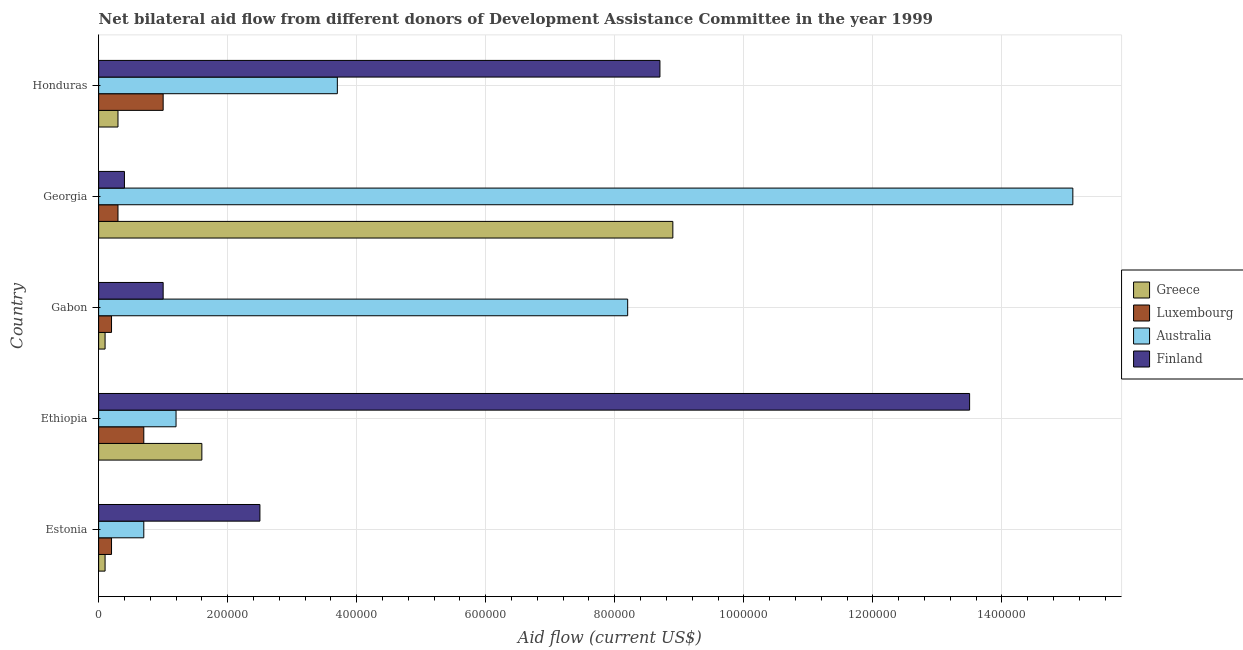How many different coloured bars are there?
Provide a succinct answer. 4. How many groups of bars are there?
Your response must be concise. 5. Are the number of bars per tick equal to the number of legend labels?
Give a very brief answer. Yes. Are the number of bars on each tick of the Y-axis equal?
Offer a very short reply. Yes. How many bars are there on the 3rd tick from the top?
Your answer should be very brief. 4. What is the label of the 4th group of bars from the top?
Give a very brief answer. Ethiopia. In how many cases, is the number of bars for a given country not equal to the number of legend labels?
Your response must be concise. 0. What is the amount of aid given by luxembourg in Georgia?
Your response must be concise. 3.00e+04. Across all countries, what is the maximum amount of aid given by australia?
Provide a short and direct response. 1.51e+06. Across all countries, what is the minimum amount of aid given by finland?
Make the answer very short. 4.00e+04. In which country was the amount of aid given by greece maximum?
Offer a terse response. Georgia. In which country was the amount of aid given by greece minimum?
Your answer should be very brief. Estonia. What is the total amount of aid given by finland in the graph?
Your response must be concise. 2.61e+06. What is the difference between the amount of aid given by australia in Estonia and the amount of aid given by greece in Gabon?
Your answer should be very brief. 6.00e+04. What is the difference between the amount of aid given by luxembourg and amount of aid given by greece in Gabon?
Ensure brevity in your answer.  10000. What is the ratio of the amount of aid given by greece in Gabon to that in Honduras?
Provide a short and direct response. 0.33. Is the amount of aid given by greece in Gabon less than that in Honduras?
Make the answer very short. Yes. Is the difference between the amount of aid given by finland in Estonia and Gabon greater than the difference between the amount of aid given by greece in Estonia and Gabon?
Make the answer very short. Yes. What is the difference between the highest and the lowest amount of aid given by finland?
Your answer should be very brief. 1.31e+06. Is the sum of the amount of aid given by finland in Ethiopia and Honduras greater than the maximum amount of aid given by greece across all countries?
Offer a very short reply. Yes. Is it the case that in every country, the sum of the amount of aid given by greece and amount of aid given by finland is greater than the sum of amount of aid given by luxembourg and amount of aid given by australia?
Ensure brevity in your answer.  Yes. Is it the case that in every country, the sum of the amount of aid given by greece and amount of aid given by luxembourg is greater than the amount of aid given by australia?
Ensure brevity in your answer.  No. Are all the bars in the graph horizontal?
Provide a short and direct response. Yes. How many countries are there in the graph?
Ensure brevity in your answer.  5. Does the graph contain any zero values?
Your answer should be very brief. No. How many legend labels are there?
Your answer should be compact. 4. What is the title of the graph?
Give a very brief answer. Net bilateral aid flow from different donors of Development Assistance Committee in the year 1999. What is the label or title of the Y-axis?
Offer a very short reply. Country. What is the Aid flow (current US$) in Greece in Estonia?
Make the answer very short. 10000. What is the Aid flow (current US$) in Luxembourg in Estonia?
Ensure brevity in your answer.  2.00e+04. What is the Aid flow (current US$) of Australia in Estonia?
Offer a terse response. 7.00e+04. What is the Aid flow (current US$) of Finland in Estonia?
Ensure brevity in your answer.  2.50e+05. What is the Aid flow (current US$) of Greece in Ethiopia?
Your response must be concise. 1.60e+05. What is the Aid flow (current US$) in Finland in Ethiopia?
Offer a terse response. 1.35e+06. What is the Aid flow (current US$) in Australia in Gabon?
Offer a terse response. 8.20e+05. What is the Aid flow (current US$) of Finland in Gabon?
Your response must be concise. 1.00e+05. What is the Aid flow (current US$) in Greece in Georgia?
Provide a succinct answer. 8.90e+05. What is the Aid flow (current US$) of Luxembourg in Georgia?
Keep it short and to the point. 3.00e+04. What is the Aid flow (current US$) in Australia in Georgia?
Your answer should be compact. 1.51e+06. What is the Aid flow (current US$) in Finland in Georgia?
Ensure brevity in your answer.  4.00e+04. What is the Aid flow (current US$) in Greece in Honduras?
Provide a short and direct response. 3.00e+04. What is the Aid flow (current US$) in Australia in Honduras?
Offer a very short reply. 3.70e+05. What is the Aid flow (current US$) of Finland in Honduras?
Keep it short and to the point. 8.70e+05. Across all countries, what is the maximum Aid flow (current US$) of Greece?
Make the answer very short. 8.90e+05. Across all countries, what is the maximum Aid flow (current US$) of Luxembourg?
Keep it short and to the point. 1.00e+05. Across all countries, what is the maximum Aid flow (current US$) in Australia?
Provide a short and direct response. 1.51e+06. Across all countries, what is the maximum Aid flow (current US$) in Finland?
Give a very brief answer. 1.35e+06. Across all countries, what is the minimum Aid flow (current US$) of Greece?
Make the answer very short. 10000. What is the total Aid flow (current US$) of Greece in the graph?
Offer a terse response. 1.10e+06. What is the total Aid flow (current US$) of Australia in the graph?
Your response must be concise. 2.89e+06. What is the total Aid flow (current US$) of Finland in the graph?
Keep it short and to the point. 2.61e+06. What is the difference between the Aid flow (current US$) of Greece in Estonia and that in Ethiopia?
Ensure brevity in your answer.  -1.50e+05. What is the difference between the Aid flow (current US$) in Australia in Estonia and that in Ethiopia?
Provide a succinct answer. -5.00e+04. What is the difference between the Aid flow (current US$) in Finland in Estonia and that in Ethiopia?
Provide a succinct answer. -1.10e+06. What is the difference between the Aid flow (current US$) of Greece in Estonia and that in Gabon?
Provide a short and direct response. 0. What is the difference between the Aid flow (current US$) of Luxembourg in Estonia and that in Gabon?
Offer a terse response. 0. What is the difference between the Aid flow (current US$) of Australia in Estonia and that in Gabon?
Provide a short and direct response. -7.50e+05. What is the difference between the Aid flow (current US$) in Greece in Estonia and that in Georgia?
Offer a very short reply. -8.80e+05. What is the difference between the Aid flow (current US$) in Luxembourg in Estonia and that in Georgia?
Keep it short and to the point. -10000. What is the difference between the Aid flow (current US$) of Australia in Estonia and that in Georgia?
Your answer should be compact. -1.44e+06. What is the difference between the Aid flow (current US$) in Finland in Estonia and that in Georgia?
Offer a terse response. 2.10e+05. What is the difference between the Aid flow (current US$) of Luxembourg in Estonia and that in Honduras?
Offer a very short reply. -8.00e+04. What is the difference between the Aid flow (current US$) in Australia in Estonia and that in Honduras?
Your answer should be compact. -3.00e+05. What is the difference between the Aid flow (current US$) of Finland in Estonia and that in Honduras?
Provide a succinct answer. -6.20e+05. What is the difference between the Aid flow (current US$) in Australia in Ethiopia and that in Gabon?
Your response must be concise. -7.00e+05. What is the difference between the Aid flow (current US$) in Finland in Ethiopia and that in Gabon?
Make the answer very short. 1.25e+06. What is the difference between the Aid flow (current US$) in Greece in Ethiopia and that in Georgia?
Offer a very short reply. -7.30e+05. What is the difference between the Aid flow (current US$) of Luxembourg in Ethiopia and that in Georgia?
Your response must be concise. 4.00e+04. What is the difference between the Aid flow (current US$) of Australia in Ethiopia and that in Georgia?
Give a very brief answer. -1.39e+06. What is the difference between the Aid flow (current US$) of Finland in Ethiopia and that in Georgia?
Ensure brevity in your answer.  1.31e+06. What is the difference between the Aid flow (current US$) in Finland in Ethiopia and that in Honduras?
Your response must be concise. 4.80e+05. What is the difference between the Aid flow (current US$) in Greece in Gabon and that in Georgia?
Make the answer very short. -8.80e+05. What is the difference between the Aid flow (current US$) of Australia in Gabon and that in Georgia?
Your answer should be very brief. -6.90e+05. What is the difference between the Aid flow (current US$) in Finland in Gabon and that in Honduras?
Offer a terse response. -7.70e+05. What is the difference between the Aid flow (current US$) of Greece in Georgia and that in Honduras?
Offer a very short reply. 8.60e+05. What is the difference between the Aid flow (current US$) in Australia in Georgia and that in Honduras?
Your answer should be very brief. 1.14e+06. What is the difference between the Aid flow (current US$) in Finland in Georgia and that in Honduras?
Provide a short and direct response. -8.30e+05. What is the difference between the Aid flow (current US$) in Greece in Estonia and the Aid flow (current US$) in Luxembourg in Ethiopia?
Make the answer very short. -6.00e+04. What is the difference between the Aid flow (current US$) of Greece in Estonia and the Aid flow (current US$) of Australia in Ethiopia?
Your answer should be very brief. -1.10e+05. What is the difference between the Aid flow (current US$) in Greece in Estonia and the Aid flow (current US$) in Finland in Ethiopia?
Your answer should be compact. -1.34e+06. What is the difference between the Aid flow (current US$) in Luxembourg in Estonia and the Aid flow (current US$) in Finland in Ethiopia?
Keep it short and to the point. -1.33e+06. What is the difference between the Aid flow (current US$) in Australia in Estonia and the Aid flow (current US$) in Finland in Ethiopia?
Offer a terse response. -1.28e+06. What is the difference between the Aid flow (current US$) of Greece in Estonia and the Aid flow (current US$) of Luxembourg in Gabon?
Keep it short and to the point. -10000. What is the difference between the Aid flow (current US$) of Greece in Estonia and the Aid flow (current US$) of Australia in Gabon?
Offer a terse response. -8.10e+05. What is the difference between the Aid flow (current US$) in Greece in Estonia and the Aid flow (current US$) in Finland in Gabon?
Give a very brief answer. -9.00e+04. What is the difference between the Aid flow (current US$) of Luxembourg in Estonia and the Aid flow (current US$) of Australia in Gabon?
Ensure brevity in your answer.  -8.00e+05. What is the difference between the Aid flow (current US$) of Luxembourg in Estonia and the Aid flow (current US$) of Finland in Gabon?
Offer a very short reply. -8.00e+04. What is the difference between the Aid flow (current US$) of Australia in Estonia and the Aid flow (current US$) of Finland in Gabon?
Offer a very short reply. -3.00e+04. What is the difference between the Aid flow (current US$) of Greece in Estonia and the Aid flow (current US$) of Luxembourg in Georgia?
Provide a short and direct response. -2.00e+04. What is the difference between the Aid flow (current US$) in Greece in Estonia and the Aid flow (current US$) in Australia in Georgia?
Provide a succinct answer. -1.50e+06. What is the difference between the Aid flow (current US$) of Greece in Estonia and the Aid flow (current US$) of Finland in Georgia?
Offer a terse response. -3.00e+04. What is the difference between the Aid flow (current US$) in Luxembourg in Estonia and the Aid flow (current US$) in Australia in Georgia?
Offer a terse response. -1.49e+06. What is the difference between the Aid flow (current US$) of Greece in Estonia and the Aid flow (current US$) of Australia in Honduras?
Provide a short and direct response. -3.60e+05. What is the difference between the Aid flow (current US$) in Greece in Estonia and the Aid flow (current US$) in Finland in Honduras?
Make the answer very short. -8.60e+05. What is the difference between the Aid flow (current US$) in Luxembourg in Estonia and the Aid flow (current US$) in Australia in Honduras?
Your response must be concise. -3.50e+05. What is the difference between the Aid flow (current US$) in Luxembourg in Estonia and the Aid flow (current US$) in Finland in Honduras?
Make the answer very short. -8.50e+05. What is the difference between the Aid flow (current US$) of Australia in Estonia and the Aid flow (current US$) of Finland in Honduras?
Offer a very short reply. -8.00e+05. What is the difference between the Aid flow (current US$) in Greece in Ethiopia and the Aid flow (current US$) in Australia in Gabon?
Offer a very short reply. -6.60e+05. What is the difference between the Aid flow (current US$) of Luxembourg in Ethiopia and the Aid flow (current US$) of Australia in Gabon?
Give a very brief answer. -7.50e+05. What is the difference between the Aid flow (current US$) in Australia in Ethiopia and the Aid flow (current US$) in Finland in Gabon?
Ensure brevity in your answer.  2.00e+04. What is the difference between the Aid flow (current US$) in Greece in Ethiopia and the Aid flow (current US$) in Australia in Georgia?
Offer a terse response. -1.35e+06. What is the difference between the Aid flow (current US$) in Greece in Ethiopia and the Aid flow (current US$) in Finland in Georgia?
Provide a succinct answer. 1.20e+05. What is the difference between the Aid flow (current US$) of Luxembourg in Ethiopia and the Aid flow (current US$) of Australia in Georgia?
Ensure brevity in your answer.  -1.44e+06. What is the difference between the Aid flow (current US$) of Australia in Ethiopia and the Aid flow (current US$) of Finland in Georgia?
Provide a short and direct response. 8.00e+04. What is the difference between the Aid flow (current US$) of Greece in Ethiopia and the Aid flow (current US$) of Luxembourg in Honduras?
Your answer should be very brief. 6.00e+04. What is the difference between the Aid flow (current US$) in Greece in Ethiopia and the Aid flow (current US$) in Australia in Honduras?
Ensure brevity in your answer.  -2.10e+05. What is the difference between the Aid flow (current US$) of Greece in Ethiopia and the Aid flow (current US$) of Finland in Honduras?
Your answer should be very brief. -7.10e+05. What is the difference between the Aid flow (current US$) of Luxembourg in Ethiopia and the Aid flow (current US$) of Australia in Honduras?
Your answer should be very brief. -3.00e+05. What is the difference between the Aid flow (current US$) of Luxembourg in Ethiopia and the Aid flow (current US$) of Finland in Honduras?
Offer a terse response. -8.00e+05. What is the difference between the Aid flow (current US$) in Australia in Ethiopia and the Aid flow (current US$) in Finland in Honduras?
Your response must be concise. -7.50e+05. What is the difference between the Aid flow (current US$) in Greece in Gabon and the Aid flow (current US$) in Australia in Georgia?
Make the answer very short. -1.50e+06. What is the difference between the Aid flow (current US$) of Greece in Gabon and the Aid flow (current US$) of Finland in Georgia?
Your answer should be compact. -3.00e+04. What is the difference between the Aid flow (current US$) of Luxembourg in Gabon and the Aid flow (current US$) of Australia in Georgia?
Ensure brevity in your answer.  -1.49e+06. What is the difference between the Aid flow (current US$) in Australia in Gabon and the Aid flow (current US$) in Finland in Georgia?
Keep it short and to the point. 7.80e+05. What is the difference between the Aid flow (current US$) of Greece in Gabon and the Aid flow (current US$) of Luxembourg in Honduras?
Provide a succinct answer. -9.00e+04. What is the difference between the Aid flow (current US$) in Greece in Gabon and the Aid flow (current US$) in Australia in Honduras?
Provide a succinct answer. -3.60e+05. What is the difference between the Aid flow (current US$) of Greece in Gabon and the Aid flow (current US$) of Finland in Honduras?
Your response must be concise. -8.60e+05. What is the difference between the Aid flow (current US$) in Luxembourg in Gabon and the Aid flow (current US$) in Australia in Honduras?
Offer a very short reply. -3.50e+05. What is the difference between the Aid flow (current US$) in Luxembourg in Gabon and the Aid flow (current US$) in Finland in Honduras?
Your response must be concise. -8.50e+05. What is the difference between the Aid flow (current US$) in Greece in Georgia and the Aid flow (current US$) in Luxembourg in Honduras?
Make the answer very short. 7.90e+05. What is the difference between the Aid flow (current US$) in Greece in Georgia and the Aid flow (current US$) in Australia in Honduras?
Your answer should be compact. 5.20e+05. What is the difference between the Aid flow (current US$) of Luxembourg in Georgia and the Aid flow (current US$) of Australia in Honduras?
Offer a terse response. -3.40e+05. What is the difference between the Aid flow (current US$) of Luxembourg in Georgia and the Aid flow (current US$) of Finland in Honduras?
Offer a very short reply. -8.40e+05. What is the difference between the Aid flow (current US$) of Australia in Georgia and the Aid flow (current US$) of Finland in Honduras?
Make the answer very short. 6.40e+05. What is the average Aid flow (current US$) of Greece per country?
Offer a terse response. 2.20e+05. What is the average Aid flow (current US$) of Luxembourg per country?
Keep it short and to the point. 4.80e+04. What is the average Aid flow (current US$) of Australia per country?
Make the answer very short. 5.78e+05. What is the average Aid flow (current US$) of Finland per country?
Offer a terse response. 5.22e+05. What is the difference between the Aid flow (current US$) in Greece and Aid flow (current US$) in Luxembourg in Estonia?
Offer a terse response. -10000. What is the difference between the Aid flow (current US$) in Greece and Aid flow (current US$) in Luxembourg in Ethiopia?
Offer a terse response. 9.00e+04. What is the difference between the Aid flow (current US$) of Greece and Aid flow (current US$) of Finland in Ethiopia?
Your response must be concise. -1.19e+06. What is the difference between the Aid flow (current US$) in Luxembourg and Aid flow (current US$) in Australia in Ethiopia?
Your answer should be compact. -5.00e+04. What is the difference between the Aid flow (current US$) in Luxembourg and Aid flow (current US$) in Finland in Ethiopia?
Ensure brevity in your answer.  -1.28e+06. What is the difference between the Aid flow (current US$) in Australia and Aid flow (current US$) in Finland in Ethiopia?
Give a very brief answer. -1.23e+06. What is the difference between the Aid flow (current US$) of Greece and Aid flow (current US$) of Australia in Gabon?
Provide a short and direct response. -8.10e+05. What is the difference between the Aid flow (current US$) of Greece and Aid flow (current US$) of Finland in Gabon?
Offer a terse response. -9.00e+04. What is the difference between the Aid flow (current US$) in Luxembourg and Aid flow (current US$) in Australia in Gabon?
Make the answer very short. -8.00e+05. What is the difference between the Aid flow (current US$) in Australia and Aid flow (current US$) in Finland in Gabon?
Keep it short and to the point. 7.20e+05. What is the difference between the Aid flow (current US$) in Greece and Aid flow (current US$) in Luxembourg in Georgia?
Your answer should be compact. 8.60e+05. What is the difference between the Aid flow (current US$) in Greece and Aid flow (current US$) in Australia in Georgia?
Your answer should be compact. -6.20e+05. What is the difference between the Aid flow (current US$) of Greece and Aid flow (current US$) of Finland in Georgia?
Offer a very short reply. 8.50e+05. What is the difference between the Aid flow (current US$) in Luxembourg and Aid flow (current US$) in Australia in Georgia?
Offer a very short reply. -1.48e+06. What is the difference between the Aid flow (current US$) of Australia and Aid flow (current US$) of Finland in Georgia?
Your answer should be very brief. 1.47e+06. What is the difference between the Aid flow (current US$) of Greece and Aid flow (current US$) of Australia in Honduras?
Give a very brief answer. -3.40e+05. What is the difference between the Aid flow (current US$) in Greece and Aid flow (current US$) in Finland in Honduras?
Offer a very short reply. -8.40e+05. What is the difference between the Aid flow (current US$) of Luxembourg and Aid flow (current US$) of Australia in Honduras?
Make the answer very short. -2.70e+05. What is the difference between the Aid flow (current US$) of Luxembourg and Aid flow (current US$) of Finland in Honduras?
Give a very brief answer. -7.70e+05. What is the difference between the Aid flow (current US$) in Australia and Aid flow (current US$) in Finland in Honduras?
Give a very brief answer. -5.00e+05. What is the ratio of the Aid flow (current US$) in Greece in Estonia to that in Ethiopia?
Your response must be concise. 0.06. What is the ratio of the Aid flow (current US$) in Luxembourg in Estonia to that in Ethiopia?
Ensure brevity in your answer.  0.29. What is the ratio of the Aid flow (current US$) of Australia in Estonia to that in Ethiopia?
Provide a short and direct response. 0.58. What is the ratio of the Aid flow (current US$) in Finland in Estonia to that in Ethiopia?
Your answer should be compact. 0.19. What is the ratio of the Aid flow (current US$) in Australia in Estonia to that in Gabon?
Keep it short and to the point. 0.09. What is the ratio of the Aid flow (current US$) of Finland in Estonia to that in Gabon?
Provide a succinct answer. 2.5. What is the ratio of the Aid flow (current US$) of Greece in Estonia to that in Georgia?
Your answer should be compact. 0.01. What is the ratio of the Aid flow (current US$) in Australia in Estonia to that in Georgia?
Your answer should be very brief. 0.05. What is the ratio of the Aid flow (current US$) in Finland in Estonia to that in Georgia?
Keep it short and to the point. 6.25. What is the ratio of the Aid flow (current US$) of Luxembourg in Estonia to that in Honduras?
Your answer should be compact. 0.2. What is the ratio of the Aid flow (current US$) of Australia in Estonia to that in Honduras?
Your response must be concise. 0.19. What is the ratio of the Aid flow (current US$) of Finland in Estonia to that in Honduras?
Your response must be concise. 0.29. What is the ratio of the Aid flow (current US$) of Greece in Ethiopia to that in Gabon?
Your answer should be very brief. 16. What is the ratio of the Aid flow (current US$) in Luxembourg in Ethiopia to that in Gabon?
Your answer should be very brief. 3.5. What is the ratio of the Aid flow (current US$) in Australia in Ethiopia to that in Gabon?
Your response must be concise. 0.15. What is the ratio of the Aid flow (current US$) in Finland in Ethiopia to that in Gabon?
Keep it short and to the point. 13.5. What is the ratio of the Aid flow (current US$) in Greece in Ethiopia to that in Georgia?
Your answer should be very brief. 0.18. What is the ratio of the Aid flow (current US$) in Luxembourg in Ethiopia to that in Georgia?
Ensure brevity in your answer.  2.33. What is the ratio of the Aid flow (current US$) of Australia in Ethiopia to that in Georgia?
Your response must be concise. 0.08. What is the ratio of the Aid flow (current US$) in Finland in Ethiopia to that in Georgia?
Offer a terse response. 33.75. What is the ratio of the Aid flow (current US$) of Greece in Ethiopia to that in Honduras?
Offer a very short reply. 5.33. What is the ratio of the Aid flow (current US$) of Australia in Ethiopia to that in Honduras?
Offer a very short reply. 0.32. What is the ratio of the Aid flow (current US$) of Finland in Ethiopia to that in Honduras?
Give a very brief answer. 1.55. What is the ratio of the Aid flow (current US$) in Greece in Gabon to that in Georgia?
Offer a very short reply. 0.01. What is the ratio of the Aid flow (current US$) in Luxembourg in Gabon to that in Georgia?
Provide a succinct answer. 0.67. What is the ratio of the Aid flow (current US$) in Australia in Gabon to that in Georgia?
Your answer should be compact. 0.54. What is the ratio of the Aid flow (current US$) in Finland in Gabon to that in Georgia?
Offer a terse response. 2.5. What is the ratio of the Aid flow (current US$) of Greece in Gabon to that in Honduras?
Your answer should be compact. 0.33. What is the ratio of the Aid flow (current US$) of Luxembourg in Gabon to that in Honduras?
Your answer should be compact. 0.2. What is the ratio of the Aid flow (current US$) of Australia in Gabon to that in Honduras?
Provide a succinct answer. 2.22. What is the ratio of the Aid flow (current US$) of Finland in Gabon to that in Honduras?
Your answer should be very brief. 0.11. What is the ratio of the Aid flow (current US$) of Greece in Georgia to that in Honduras?
Provide a short and direct response. 29.67. What is the ratio of the Aid flow (current US$) in Australia in Georgia to that in Honduras?
Your answer should be very brief. 4.08. What is the ratio of the Aid flow (current US$) of Finland in Georgia to that in Honduras?
Your answer should be compact. 0.05. What is the difference between the highest and the second highest Aid flow (current US$) in Greece?
Your response must be concise. 7.30e+05. What is the difference between the highest and the second highest Aid flow (current US$) of Luxembourg?
Keep it short and to the point. 3.00e+04. What is the difference between the highest and the second highest Aid flow (current US$) in Australia?
Your answer should be very brief. 6.90e+05. What is the difference between the highest and the lowest Aid flow (current US$) in Greece?
Offer a terse response. 8.80e+05. What is the difference between the highest and the lowest Aid flow (current US$) in Luxembourg?
Keep it short and to the point. 8.00e+04. What is the difference between the highest and the lowest Aid flow (current US$) in Australia?
Offer a very short reply. 1.44e+06. What is the difference between the highest and the lowest Aid flow (current US$) of Finland?
Provide a succinct answer. 1.31e+06. 